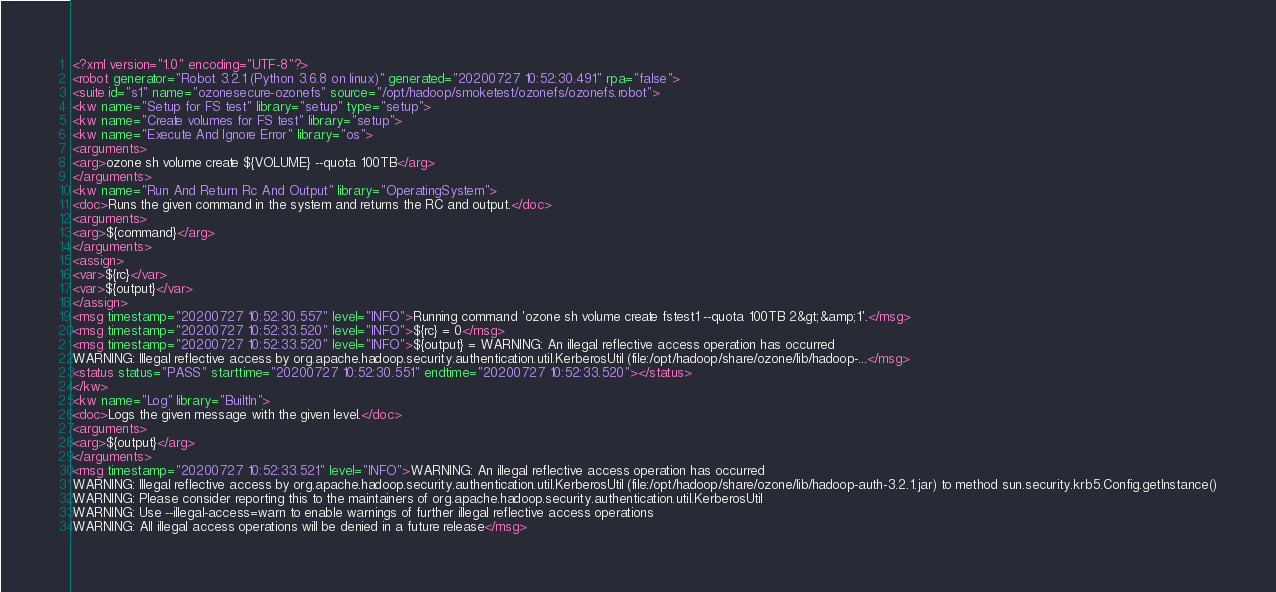Convert code to text. <code><loc_0><loc_0><loc_500><loc_500><_XML_><?xml version="1.0" encoding="UTF-8"?>
<robot generator="Robot 3.2.1 (Python 3.6.8 on linux)" generated="20200727 10:52:30.491" rpa="false">
<suite id="s1" name="ozonesecure-ozonefs" source="/opt/hadoop/smoketest/ozonefs/ozonefs.robot">
<kw name="Setup for FS test" library="setup" type="setup">
<kw name="Create volumes for FS test" library="setup">
<kw name="Execute And Ignore Error" library="os">
<arguments>
<arg>ozone sh volume create ${VOLUME} --quota 100TB</arg>
</arguments>
<kw name="Run And Return Rc And Output" library="OperatingSystem">
<doc>Runs the given command in the system and returns the RC and output.</doc>
<arguments>
<arg>${command}</arg>
</arguments>
<assign>
<var>${rc}</var>
<var>${output}</var>
</assign>
<msg timestamp="20200727 10:52:30.557" level="INFO">Running command 'ozone sh volume create fstest1 --quota 100TB 2&gt;&amp;1'.</msg>
<msg timestamp="20200727 10:52:33.520" level="INFO">${rc} = 0</msg>
<msg timestamp="20200727 10:52:33.520" level="INFO">${output} = WARNING: An illegal reflective access operation has occurred
WARNING: Illegal reflective access by org.apache.hadoop.security.authentication.util.KerberosUtil (file:/opt/hadoop/share/ozone/lib/hadoop-...</msg>
<status status="PASS" starttime="20200727 10:52:30.551" endtime="20200727 10:52:33.520"></status>
</kw>
<kw name="Log" library="BuiltIn">
<doc>Logs the given message with the given level.</doc>
<arguments>
<arg>${output}</arg>
</arguments>
<msg timestamp="20200727 10:52:33.521" level="INFO">WARNING: An illegal reflective access operation has occurred
WARNING: Illegal reflective access by org.apache.hadoop.security.authentication.util.KerberosUtil (file:/opt/hadoop/share/ozone/lib/hadoop-auth-3.2.1.jar) to method sun.security.krb5.Config.getInstance()
WARNING: Please consider reporting this to the maintainers of org.apache.hadoop.security.authentication.util.KerberosUtil
WARNING: Use --illegal-access=warn to enable warnings of further illegal reflective access operations
WARNING: All illegal access operations will be denied in a future release</msg></code> 